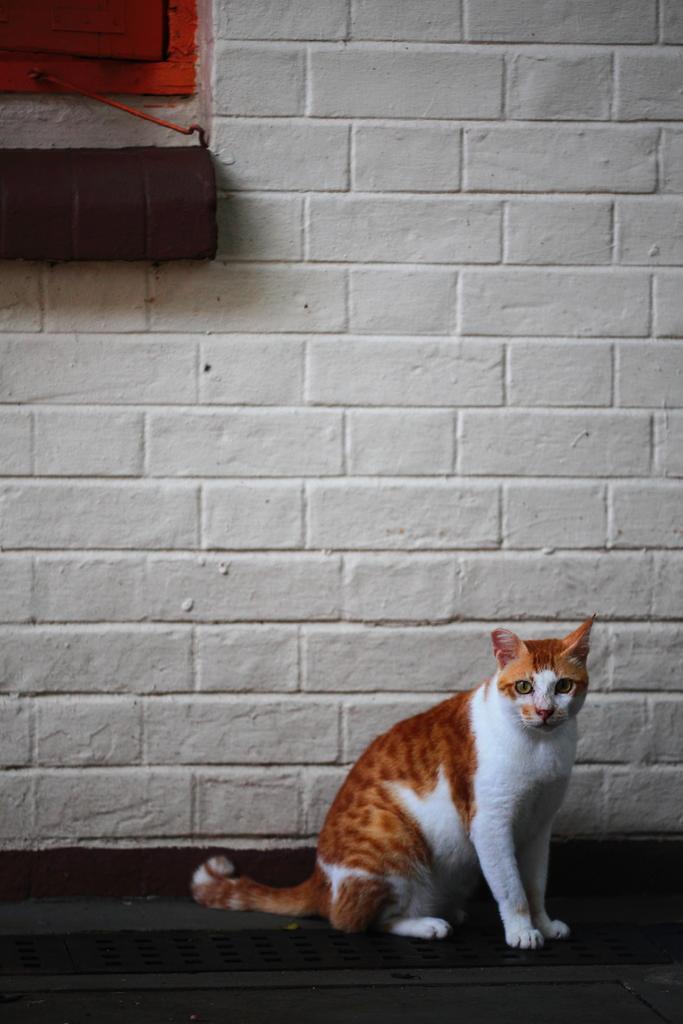Describe this image in one or two sentences. In this image there is a cat sitting on the floor, behind that there is a wall on which we can see there is a window and some object. 